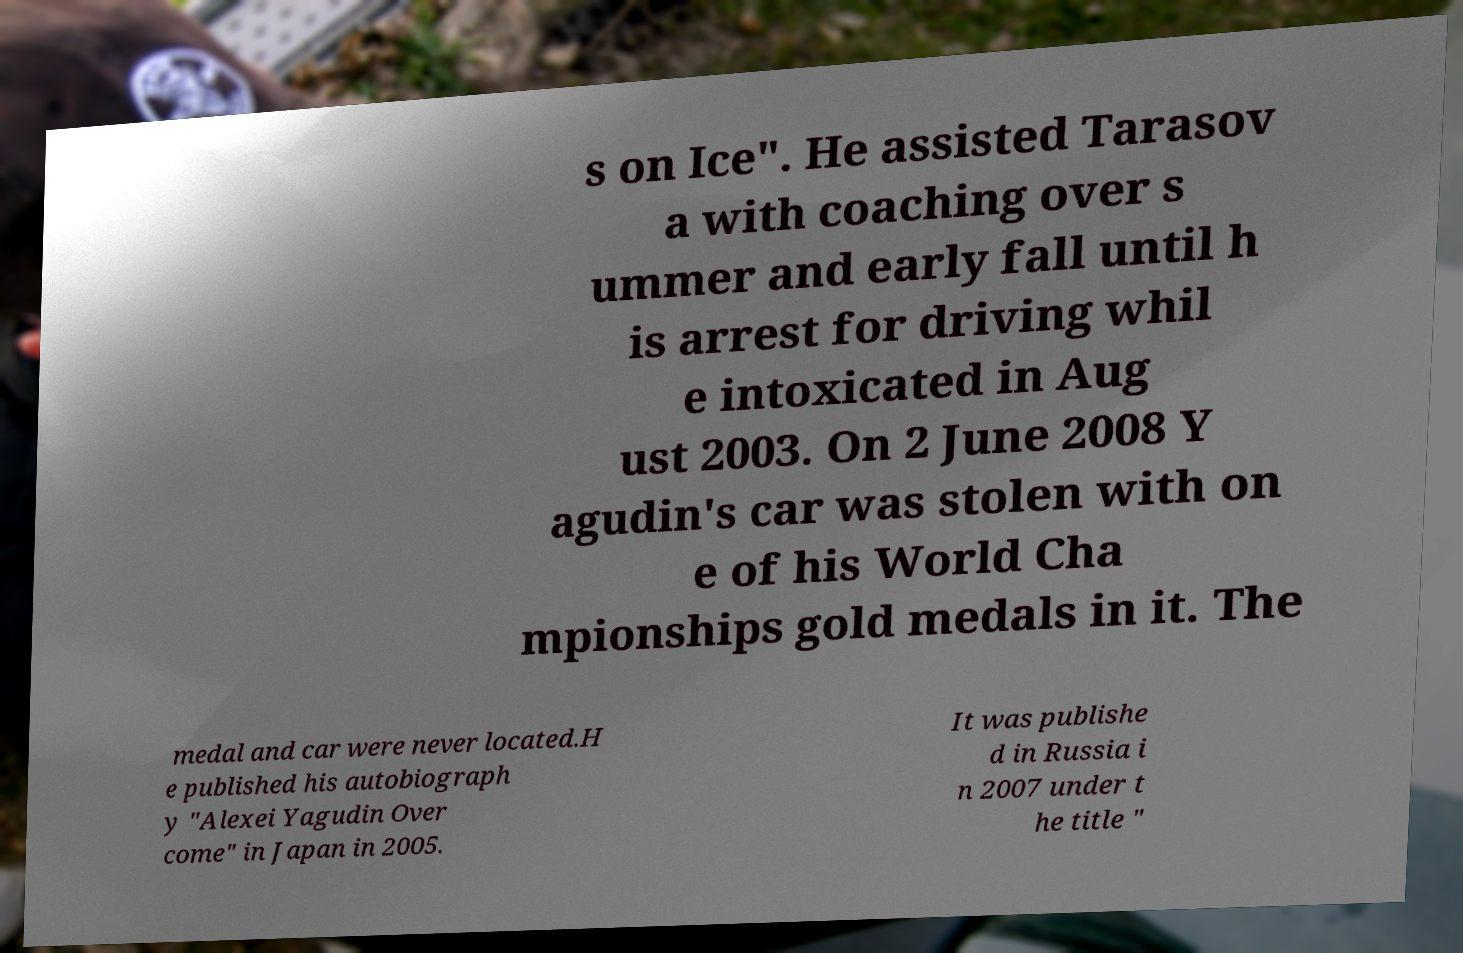There's text embedded in this image that I need extracted. Can you transcribe it verbatim? s on Ice". He assisted Tarasov a with coaching over s ummer and early fall until h is arrest for driving whil e intoxicated in Aug ust 2003. On 2 June 2008 Y agudin's car was stolen with on e of his World Cha mpionships gold medals in it. The medal and car were never located.H e published his autobiograph y "Alexei Yagudin Over come" in Japan in 2005. It was publishe d in Russia i n 2007 under t he title " 